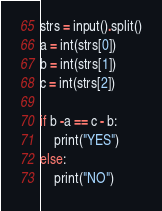Convert code to text. <code><loc_0><loc_0><loc_500><loc_500><_Python_>strs = input().split()
a = int(strs[0])
b = int(strs[1])
c = int(strs[2])

if b -a == c - b:
    print("YES")
else:
    print("NO")

</code> 